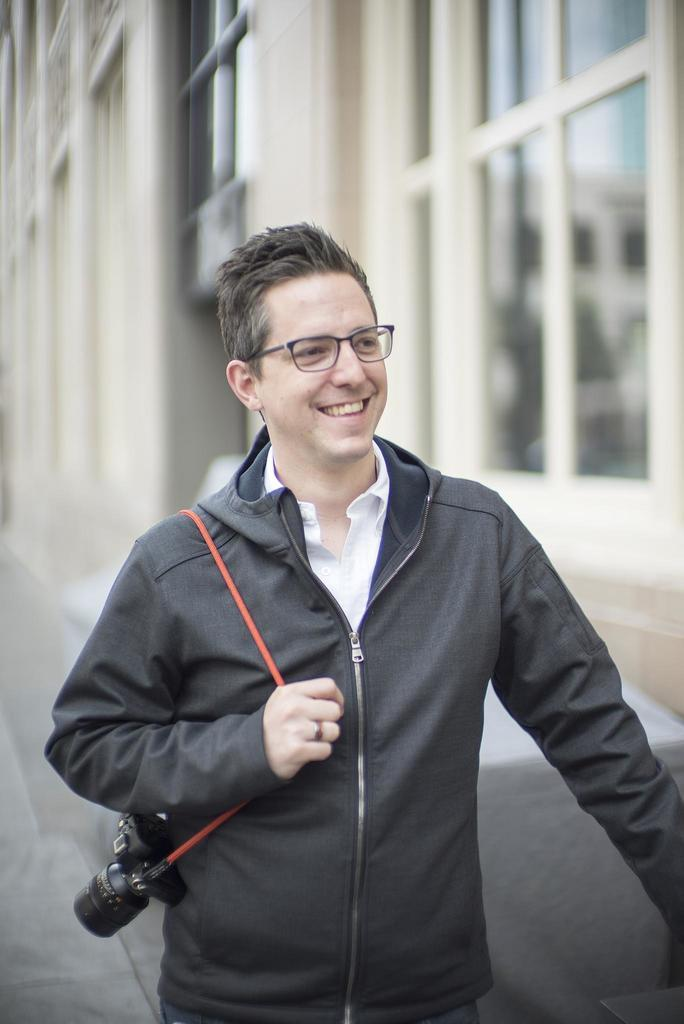What is the person in the image doing? The person is standing in the image and holding a camera. What is the person wearing? The person is wearing a black coat and a white shirt. What can be seen in the background of the image? There is a building visible in the background. What type of windows are on the building? The building has glass windows. What type of sticks can be seen in the person's hand in the image? There are no sticks visible in the person's hand in the image; they are holding a camera. 